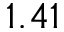Convert formula to latex. <formula><loc_0><loc_0><loc_500><loc_500>1 . 4 1</formula> 